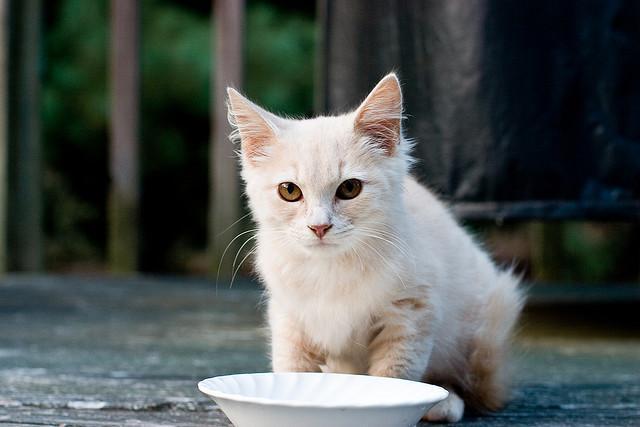How many people are there?
Give a very brief answer. 0. 